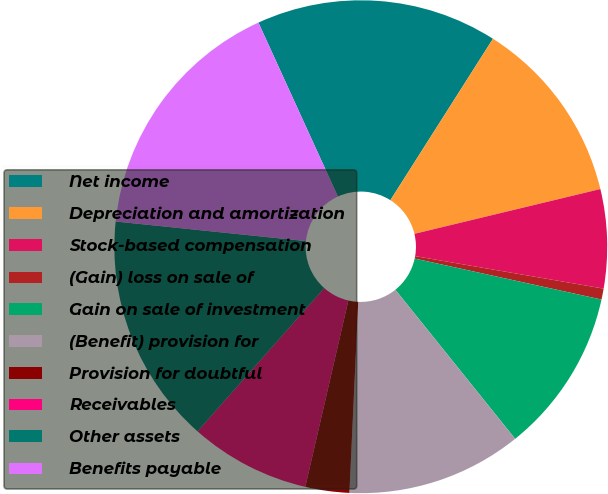<chart> <loc_0><loc_0><loc_500><loc_500><pie_chart><fcel>Net income<fcel>Depreciation and amortization<fcel>Stock-based compensation<fcel>(Gain) loss on sale of<fcel>Gain on sale of investment<fcel>(Benefit) provision for<fcel>Provision for doubtful<fcel>Receivables<fcel>Other assets<fcel>Benefits payable<nl><fcel>15.83%<fcel>12.23%<fcel>6.48%<fcel>0.72%<fcel>10.79%<fcel>11.51%<fcel>2.88%<fcel>7.91%<fcel>15.11%<fcel>16.55%<nl></chart> 